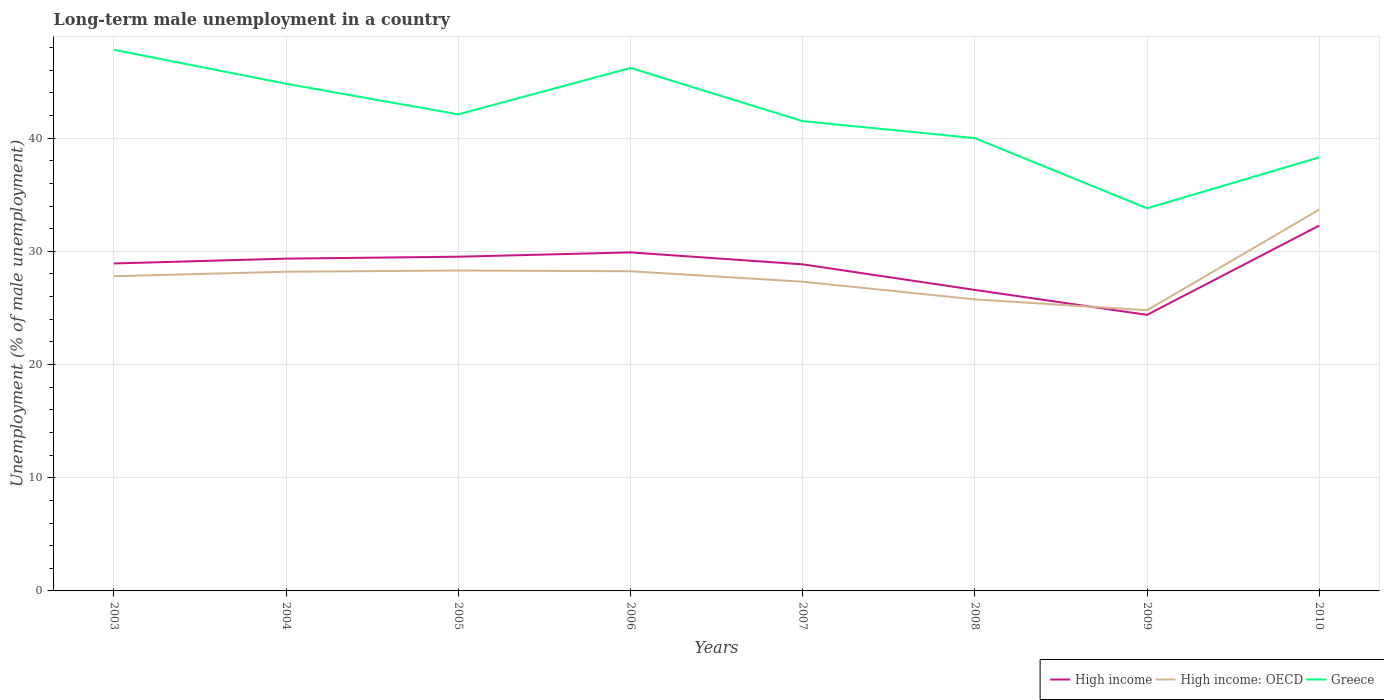How many different coloured lines are there?
Give a very brief answer. 3. Does the line corresponding to Greece intersect with the line corresponding to High income?
Give a very brief answer. No. Is the number of lines equal to the number of legend labels?
Offer a terse response. Yes. Across all years, what is the maximum percentage of long-term unemployed male population in High income?
Give a very brief answer. 24.39. What is the total percentage of long-term unemployed male population in High income in the graph?
Give a very brief answer. 1.06. What is the difference between the highest and the second highest percentage of long-term unemployed male population in High income?
Offer a terse response. 7.89. What is the difference between the highest and the lowest percentage of long-term unemployed male population in High income: OECD?
Provide a succinct answer. 4. Is the percentage of long-term unemployed male population in High income strictly greater than the percentage of long-term unemployed male population in Greece over the years?
Your answer should be compact. Yes. How many years are there in the graph?
Provide a short and direct response. 8. What is the difference between two consecutive major ticks on the Y-axis?
Keep it short and to the point. 10. Are the values on the major ticks of Y-axis written in scientific E-notation?
Make the answer very short. No. Does the graph contain any zero values?
Make the answer very short. No. Does the graph contain grids?
Give a very brief answer. Yes. How are the legend labels stacked?
Offer a very short reply. Horizontal. What is the title of the graph?
Give a very brief answer. Long-term male unemployment in a country. What is the label or title of the Y-axis?
Keep it short and to the point. Unemployment (% of male unemployment). What is the Unemployment (% of male unemployment) of High income in 2003?
Keep it short and to the point. 28.93. What is the Unemployment (% of male unemployment) in High income: OECD in 2003?
Offer a very short reply. 27.8. What is the Unemployment (% of male unemployment) of Greece in 2003?
Ensure brevity in your answer.  47.8. What is the Unemployment (% of male unemployment) in High income in 2004?
Your answer should be compact. 29.36. What is the Unemployment (% of male unemployment) in High income: OECD in 2004?
Offer a very short reply. 28.2. What is the Unemployment (% of male unemployment) in Greece in 2004?
Ensure brevity in your answer.  44.8. What is the Unemployment (% of male unemployment) in High income in 2005?
Your answer should be very brief. 29.52. What is the Unemployment (% of male unemployment) in High income: OECD in 2005?
Your response must be concise. 28.3. What is the Unemployment (% of male unemployment) in Greece in 2005?
Give a very brief answer. 42.1. What is the Unemployment (% of male unemployment) of High income in 2006?
Your answer should be compact. 29.91. What is the Unemployment (% of male unemployment) in High income: OECD in 2006?
Give a very brief answer. 28.24. What is the Unemployment (% of male unemployment) in Greece in 2006?
Ensure brevity in your answer.  46.2. What is the Unemployment (% of male unemployment) of High income in 2007?
Your answer should be very brief. 28.85. What is the Unemployment (% of male unemployment) of High income: OECD in 2007?
Your response must be concise. 27.32. What is the Unemployment (% of male unemployment) in Greece in 2007?
Your answer should be compact. 41.5. What is the Unemployment (% of male unemployment) of High income in 2008?
Offer a very short reply. 26.59. What is the Unemployment (% of male unemployment) of High income: OECD in 2008?
Give a very brief answer. 25.75. What is the Unemployment (% of male unemployment) of High income in 2009?
Provide a succinct answer. 24.39. What is the Unemployment (% of male unemployment) in High income: OECD in 2009?
Offer a terse response. 24.79. What is the Unemployment (% of male unemployment) of Greece in 2009?
Provide a succinct answer. 33.8. What is the Unemployment (% of male unemployment) in High income in 2010?
Provide a succinct answer. 32.28. What is the Unemployment (% of male unemployment) of High income: OECD in 2010?
Provide a succinct answer. 33.69. What is the Unemployment (% of male unemployment) in Greece in 2010?
Ensure brevity in your answer.  38.3. Across all years, what is the maximum Unemployment (% of male unemployment) of High income?
Give a very brief answer. 32.28. Across all years, what is the maximum Unemployment (% of male unemployment) of High income: OECD?
Your response must be concise. 33.69. Across all years, what is the maximum Unemployment (% of male unemployment) in Greece?
Provide a succinct answer. 47.8. Across all years, what is the minimum Unemployment (% of male unemployment) in High income?
Your response must be concise. 24.39. Across all years, what is the minimum Unemployment (% of male unemployment) in High income: OECD?
Ensure brevity in your answer.  24.79. Across all years, what is the minimum Unemployment (% of male unemployment) in Greece?
Offer a very short reply. 33.8. What is the total Unemployment (% of male unemployment) in High income in the graph?
Provide a succinct answer. 229.81. What is the total Unemployment (% of male unemployment) in High income: OECD in the graph?
Your response must be concise. 224.09. What is the total Unemployment (% of male unemployment) in Greece in the graph?
Ensure brevity in your answer.  334.5. What is the difference between the Unemployment (% of male unemployment) of High income in 2003 and that in 2004?
Your answer should be very brief. -0.43. What is the difference between the Unemployment (% of male unemployment) in High income: OECD in 2003 and that in 2004?
Make the answer very short. -0.39. What is the difference between the Unemployment (% of male unemployment) in Greece in 2003 and that in 2004?
Give a very brief answer. 3. What is the difference between the Unemployment (% of male unemployment) in High income in 2003 and that in 2005?
Your answer should be very brief. -0.6. What is the difference between the Unemployment (% of male unemployment) of High income: OECD in 2003 and that in 2005?
Provide a short and direct response. -0.5. What is the difference between the Unemployment (% of male unemployment) in Greece in 2003 and that in 2005?
Ensure brevity in your answer.  5.7. What is the difference between the Unemployment (% of male unemployment) in High income in 2003 and that in 2006?
Provide a short and direct response. -0.98. What is the difference between the Unemployment (% of male unemployment) in High income: OECD in 2003 and that in 2006?
Make the answer very short. -0.44. What is the difference between the Unemployment (% of male unemployment) of Greece in 2003 and that in 2006?
Give a very brief answer. 1.6. What is the difference between the Unemployment (% of male unemployment) of High income in 2003 and that in 2007?
Keep it short and to the point. 0.08. What is the difference between the Unemployment (% of male unemployment) in High income: OECD in 2003 and that in 2007?
Keep it short and to the point. 0.48. What is the difference between the Unemployment (% of male unemployment) in High income in 2003 and that in 2008?
Provide a succinct answer. 2.34. What is the difference between the Unemployment (% of male unemployment) in High income: OECD in 2003 and that in 2008?
Offer a very short reply. 2.05. What is the difference between the Unemployment (% of male unemployment) of Greece in 2003 and that in 2008?
Provide a succinct answer. 7.8. What is the difference between the Unemployment (% of male unemployment) in High income in 2003 and that in 2009?
Ensure brevity in your answer.  4.54. What is the difference between the Unemployment (% of male unemployment) of High income: OECD in 2003 and that in 2009?
Your answer should be very brief. 3.01. What is the difference between the Unemployment (% of male unemployment) of Greece in 2003 and that in 2009?
Your response must be concise. 14. What is the difference between the Unemployment (% of male unemployment) in High income in 2003 and that in 2010?
Your answer should be compact. -3.35. What is the difference between the Unemployment (% of male unemployment) in High income: OECD in 2003 and that in 2010?
Make the answer very short. -5.88. What is the difference between the Unemployment (% of male unemployment) in High income in 2004 and that in 2005?
Your answer should be compact. -0.17. What is the difference between the Unemployment (% of male unemployment) in High income: OECD in 2004 and that in 2005?
Your answer should be very brief. -0.11. What is the difference between the Unemployment (% of male unemployment) in Greece in 2004 and that in 2005?
Your answer should be compact. 2.7. What is the difference between the Unemployment (% of male unemployment) in High income in 2004 and that in 2006?
Give a very brief answer. -0.55. What is the difference between the Unemployment (% of male unemployment) of High income: OECD in 2004 and that in 2006?
Provide a short and direct response. -0.04. What is the difference between the Unemployment (% of male unemployment) of High income in 2004 and that in 2007?
Provide a short and direct response. 0.51. What is the difference between the Unemployment (% of male unemployment) of High income: OECD in 2004 and that in 2007?
Make the answer very short. 0.88. What is the difference between the Unemployment (% of male unemployment) of Greece in 2004 and that in 2007?
Your answer should be compact. 3.3. What is the difference between the Unemployment (% of male unemployment) in High income in 2004 and that in 2008?
Keep it short and to the point. 2.77. What is the difference between the Unemployment (% of male unemployment) of High income: OECD in 2004 and that in 2008?
Provide a succinct answer. 2.44. What is the difference between the Unemployment (% of male unemployment) of High income in 2004 and that in 2009?
Ensure brevity in your answer.  4.97. What is the difference between the Unemployment (% of male unemployment) in High income: OECD in 2004 and that in 2009?
Ensure brevity in your answer.  3.4. What is the difference between the Unemployment (% of male unemployment) in Greece in 2004 and that in 2009?
Provide a short and direct response. 11. What is the difference between the Unemployment (% of male unemployment) in High income in 2004 and that in 2010?
Your answer should be very brief. -2.92. What is the difference between the Unemployment (% of male unemployment) in High income: OECD in 2004 and that in 2010?
Provide a short and direct response. -5.49. What is the difference between the Unemployment (% of male unemployment) in High income in 2005 and that in 2006?
Offer a terse response. -0.38. What is the difference between the Unemployment (% of male unemployment) of High income: OECD in 2005 and that in 2006?
Offer a very short reply. 0.07. What is the difference between the Unemployment (% of male unemployment) of Greece in 2005 and that in 2006?
Offer a terse response. -4.1. What is the difference between the Unemployment (% of male unemployment) of High income in 2005 and that in 2007?
Offer a very short reply. 0.67. What is the difference between the Unemployment (% of male unemployment) of High income: OECD in 2005 and that in 2007?
Provide a succinct answer. 0.99. What is the difference between the Unemployment (% of male unemployment) of Greece in 2005 and that in 2007?
Offer a terse response. 0.6. What is the difference between the Unemployment (% of male unemployment) in High income in 2005 and that in 2008?
Give a very brief answer. 2.93. What is the difference between the Unemployment (% of male unemployment) of High income: OECD in 2005 and that in 2008?
Provide a succinct answer. 2.55. What is the difference between the Unemployment (% of male unemployment) in Greece in 2005 and that in 2008?
Keep it short and to the point. 2.1. What is the difference between the Unemployment (% of male unemployment) in High income in 2005 and that in 2009?
Your response must be concise. 5.13. What is the difference between the Unemployment (% of male unemployment) in High income: OECD in 2005 and that in 2009?
Provide a succinct answer. 3.51. What is the difference between the Unemployment (% of male unemployment) in High income in 2005 and that in 2010?
Give a very brief answer. -2.75. What is the difference between the Unemployment (% of male unemployment) in High income: OECD in 2005 and that in 2010?
Offer a terse response. -5.38. What is the difference between the Unemployment (% of male unemployment) in High income in 2006 and that in 2007?
Ensure brevity in your answer.  1.06. What is the difference between the Unemployment (% of male unemployment) of High income: OECD in 2006 and that in 2007?
Make the answer very short. 0.92. What is the difference between the Unemployment (% of male unemployment) in High income in 2006 and that in 2008?
Keep it short and to the point. 3.32. What is the difference between the Unemployment (% of male unemployment) of High income: OECD in 2006 and that in 2008?
Ensure brevity in your answer.  2.49. What is the difference between the Unemployment (% of male unemployment) in Greece in 2006 and that in 2008?
Offer a very short reply. 6.2. What is the difference between the Unemployment (% of male unemployment) in High income in 2006 and that in 2009?
Make the answer very short. 5.52. What is the difference between the Unemployment (% of male unemployment) in High income: OECD in 2006 and that in 2009?
Ensure brevity in your answer.  3.45. What is the difference between the Unemployment (% of male unemployment) of High income in 2006 and that in 2010?
Provide a succinct answer. -2.37. What is the difference between the Unemployment (% of male unemployment) in High income: OECD in 2006 and that in 2010?
Your answer should be compact. -5.45. What is the difference between the Unemployment (% of male unemployment) in High income in 2007 and that in 2008?
Provide a short and direct response. 2.26. What is the difference between the Unemployment (% of male unemployment) in High income: OECD in 2007 and that in 2008?
Ensure brevity in your answer.  1.56. What is the difference between the Unemployment (% of male unemployment) of Greece in 2007 and that in 2008?
Give a very brief answer. 1.5. What is the difference between the Unemployment (% of male unemployment) in High income in 2007 and that in 2009?
Offer a terse response. 4.46. What is the difference between the Unemployment (% of male unemployment) in High income: OECD in 2007 and that in 2009?
Make the answer very short. 2.52. What is the difference between the Unemployment (% of male unemployment) in High income in 2007 and that in 2010?
Offer a terse response. -3.43. What is the difference between the Unemployment (% of male unemployment) in High income: OECD in 2007 and that in 2010?
Give a very brief answer. -6.37. What is the difference between the Unemployment (% of male unemployment) of High income in 2008 and that in 2009?
Provide a short and direct response. 2.2. What is the difference between the Unemployment (% of male unemployment) in High income: OECD in 2008 and that in 2009?
Offer a very short reply. 0.96. What is the difference between the Unemployment (% of male unemployment) in Greece in 2008 and that in 2009?
Your answer should be compact. 6.2. What is the difference between the Unemployment (% of male unemployment) of High income in 2008 and that in 2010?
Offer a terse response. -5.69. What is the difference between the Unemployment (% of male unemployment) in High income: OECD in 2008 and that in 2010?
Keep it short and to the point. -7.93. What is the difference between the Unemployment (% of male unemployment) in High income in 2009 and that in 2010?
Make the answer very short. -7.89. What is the difference between the Unemployment (% of male unemployment) in High income: OECD in 2009 and that in 2010?
Ensure brevity in your answer.  -8.89. What is the difference between the Unemployment (% of male unemployment) of Greece in 2009 and that in 2010?
Your answer should be compact. -4.5. What is the difference between the Unemployment (% of male unemployment) in High income in 2003 and the Unemployment (% of male unemployment) in High income: OECD in 2004?
Provide a succinct answer. 0.73. What is the difference between the Unemployment (% of male unemployment) in High income in 2003 and the Unemployment (% of male unemployment) in Greece in 2004?
Ensure brevity in your answer.  -15.87. What is the difference between the Unemployment (% of male unemployment) in High income: OECD in 2003 and the Unemployment (% of male unemployment) in Greece in 2004?
Your answer should be compact. -17. What is the difference between the Unemployment (% of male unemployment) in High income in 2003 and the Unemployment (% of male unemployment) in High income: OECD in 2005?
Your answer should be very brief. 0.62. What is the difference between the Unemployment (% of male unemployment) in High income in 2003 and the Unemployment (% of male unemployment) in Greece in 2005?
Keep it short and to the point. -13.17. What is the difference between the Unemployment (% of male unemployment) of High income: OECD in 2003 and the Unemployment (% of male unemployment) of Greece in 2005?
Provide a short and direct response. -14.3. What is the difference between the Unemployment (% of male unemployment) in High income in 2003 and the Unemployment (% of male unemployment) in High income: OECD in 2006?
Keep it short and to the point. 0.69. What is the difference between the Unemployment (% of male unemployment) in High income in 2003 and the Unemployment (% of male unemployment) in Greece in 2006?
Make the answer very short. -17.27. What is the difference between the Unemployment (% of male unemployment) of High income: OECD in 2003 and the Unemployment (% of male unemployment) of Greece in 2006?
Provide a short and direct response. -18.4. What is the difference between the Unemployment (% of male unemployment) of High income in 2003 and the Unemployment (% of male unemployment) of High income: OECD in 2007?
Offer a terse response. 1.61. What is the difference between the Unemployment (% of male unemployment) of High income in 2003 and the Unemployment (% of male unemployment) of Greece in 2007?
Ensure brevity in your answer.  -12.57. What is the difference between the Unemployment (% of male unemployment) of High income: OECD in 2003 and the Unemployment (% of male unemployment) of Greece in 2007?
Give a very brief answer. -13.7. What is the difference between the Unemployment (% of male unemployment) in High income in 2003 and the Unemployment (% of male unemployment) in High income: OECD in 2008?
Keep it short and to the point. 3.17. What is the difference between the Unemployment (% of male unemployment) of High income in 2003 and the Unemployment (% of male unemployment) of Greece in 2008?
Provide a short and direct response. -11.07. What is the difference between the Unemployment (% of male unemployment) of High income: OECD in 2003 and the Unemployment (% of male unemployment) of Greece in 2008?
Keep it short and to the point. -12.2. What is the difference between the Unemployment (% of male unemployment) in High income in 2003 and the Unemployment (% of male unemployment) in High income: OECD in 2009?
Offer a very short reply. 4.13. What is the difference between the Unemployment (% of male unemployment) in High income in 2003 and the Unemployment (% of male unemployment) in Greece in 2009?
Your answer should be compact. -4.87. What is the difference between the Unemployment (% of male unemployment) in High income: OECD in 2003 and the Unemployment (% of male unemployment) in Greece in 2009?
Make the answer very short. -6. What is the difference between the Unemployment (% of male unemployment) of High income in 2003 and the Unemployment (% of male unemployment) of High income: OECD in 2010?
Offer a terse response. -4.76. What is the difference between the Unemployment (% of male unemployment) of High income in 2003 and the Unemployment (% of male unemployment) of Greece in 2010?
Offer a very short reply. -9.37. What is the difference between the Unemployment (% of male unemployment) of High income: OECD in 2003 and the Unemployment (% of male unemployment) of Greece in 2010?
Ensure brevity in your answer.  -10.5. What is the difference between the Unemployment (% of male unemployment) in High income in 2004 and the Unemployment (% of male unemployment) in High income: OECD in 2005?
Ensure brevity in your answer.  1.05. What is the difference between the Unemployment (% of male unemployment) in High income in 2004 and the Unemployment (% of male unemployment) in Greece in 2005?
Provide a succinct answer. -12.74. What is the difference between the Unemployment (% of male unemployment) in High income: OECD in 2004 and the Unemployment (% of male unemployment) in Greece in 2005?
Keep it short and to the point. -13.9. What is the difference between the Unemployment (% of male unemployment) in High income in 2004 and the Unemployment (% of male unemployment) in High income: OECD in 2006?
Provide a short and direct response. 1.12. What is the difference between the Unemployment (% of male unemployment) in High income in 2004 and the Unemployment (% of male unemployment) in Greece in 2006?
Ensure brevity in your answer.  -16.84. What is the difference between the Unemployment (% of male unemployment) in High income: OECD in 2004 and the Unemployment (% of male unemployment) in Greece in 2006?
Your answer should be very brief. -18. What is the difference between the Unemployment (% of male unemployment) in High income in 2004 and the Unemployment (% of male unemployment) in High income: OECD in 2007?
Make the answer very short. 2.04. What is the difference between the Unemployment (% of male unemployment) of High income in 2004 and the Unemployment (% of male unemployment) of Greece in 2007?
Give a very brief answer. -12.14. What is the difference between the Unemployment (% of male unemployment) in High income: OECD in 2004 and the Unemployment (% of male unemployment) in Greece in 2007?
Ensure brevity in your answer.  -13.3. What is the difference between the Unemployment (% of male unemployment) in High income in 2004 and the Unemployment (% of male unemployment) in High income: OECD in 2008?
Make the answer very short. 3.6. What is the difference between the Unemployment (% of male unemployment) in High income in 2004 and the Unemployment (% of male unemployment) in Greece in 2008?
Ensure brevity in your answer.  -10.64. What is the difference between the Unemployment (% of male unemployment) of High income: OECD in 2004 and the Unemployment (% of male unemployment) of Greece in 2008?
Your answer should be compact. -11.8. What is the difference between the Unemployment (% of male unemployment) of High income in 2004 and the Unemployment (% of male unemployment) of High income: OECD in 2009?
Your answer should be very brief. 4.56. What is the difference between the Unemployment (% of male unemployment) of High income in 2004 and the Unemployment (% of male unemployment) of Greece in 2009?
Ensure brevity in your answer.  -4.44. What is the difference between the Unemployment (% of male unemployment) of High income: OECD in 2004 and the Unemployment (% of male unemployment) of Greece in 2009?
Ensure brevity in your answer.  -5.6. What is the difference between the Unemployment (% of male unemployment) in High income in 2004 and the Unemployment (% of male unemployment) in High income: OECD in 2010?
Make the answer very short. -4.33. What is the difference between the Unemployment (% of male unemployment) of High income in 2004 and the Unemployment (% of male unemployment) of Greece in 2010?
Your answer should be compact. -8.94. What is the difference between the Unemployment (% of male unemployment) of High income: OECD in 2004 and the Unemployment (% of male unemployment) of Greece in 2010?
Give a very brief answer. -10.1. What is the difference between the Unemployment (% of male unemployment) in High income in 2005 and the Unemployment (% of male unemployment) in High income: OECD in 2006?
Keep it short and to the point. 1.28. What is the difference between the Unemployment (% of male unemployment) of High income in 2005 and the Unemployment (% of male unemployment) of Greece in 2006?
Offer a terse response. -16.68. What is the difference between the Unemployment (% of male unemployment) in High income: OECD in 2005 and the Unemployment (% of male unemployment) in Greece in 2006?
Your response must be concise. -17.9. What is the difference between the Unemployment (% of male unemployment) of High income in 2005 and the Unemployment (% of male unemployment) of High income: OECD in 2007?
Your answer should be very brief. 2.21. What is the difference between the Unemployment (% of male unemployment) of High income in 2005 and the Unemployment (% of male unemployment) of Greece in 2007?
Offer a terse response. -11.98. What is the difference between the Unemployment (% of male unemployment) in High income: OECD in 2005 and the Unemployment (% of male unemployment) in Greece in 2007?
Your answer should be compact. -13.2. What is the difference between the Unemployment (% of male unemployment) of High income in 2005 and the Unemployment (% of male unemployment) of High income: OECD in 2008?
Your response must be concise. 3.77. What is the difference between the Unemployment (% of male unemployment) in High income in 2005 and the Unemployment (% of male unemployment) in Greece in 2008?
Give a very brief answer. -10.48. What is the difference between the Unemployment (% of male unemployment) in High income: OECD in 2005 and the Unemployment (% of male unemployment) in Greece in 2008?
Keep it short and to the point. -11.7. What is the difference between the Unemployment (% of male unemployment) in High income in 2005 and the Unemployment (% of male unemployment) in High income: OECD in 2009?
Provide a succinct answer. 4.73. What is the difference between the Unemployment (% of male unemployment) in High income in 2005 and the Unemployment (% of male unemployment) in Greece in 2009?
Your response must be concise. -4.28. What is the difference between the Unemployment (% of male unemployment) of High income: OECD in 2005 and the Unemployment (% of male unemployment) of Greece in 2009?
Your response must be concise. -5.5. What is the difference between the Unemployment (% of male unemployment) of High income in 2005 and the Unemployment (% of male unemployment) of High income: OECD in 2010?
Provide a succinct answer. -4.16. What is the difference between the Unemployment (% of male unemployment) in High income in 2005 and the Unemployment (% of male unemployment) in Greece in 2010?
Your response must be concise. -8.78. What is the difference between the Unemployment (% of male unemployment) of High income: OECD in 2005 and the Unemployment (% of male unemployment) of Greece in 2010?
Make the answer very short. -10. What is the difference between the Unemployment (% of male unemployment) of High income in 2006 and the Unemployment (% of male unemployment) of High income: OECD in 2007?
Offer a very short reply. 2.59. What is the difference between the Unemployment (% of male unemployment) of High income in 2006 and the Unemployment (% of male unemployment) of Greece in 2007?
Ensure brevity in your answer.  -11.59. What is the difference between the Unemployment (% of male unemployment) in High income: OECD in 2006 and the Unemployment (% of male unemployment) in Greece in 2007?
Ensure brevity in your answer.  -13.26. What is the difference between the Unemployment (% of male unemployment) in High income in 2006 and the Unemployment (% of male unemployment) in High income: OECD in 2008?
Your response must be concise. 4.15. What is the difference between the Unemployment (% of male unemployment) of High income in 2006 and the Unemployment (% of male unemployment) of Greece in 2008?
Ensure brevity in your answer.  -10.09. What is the difference between the Unemployment (% of male unemployment) in High income: OECD in 2006 and the Unemployment (% of male unemployment) in Greece in 2008?
Make the answer very short. -11.76. What is the difference between the Unemployment (% of male unemployment) in High income in 2006 and the Unemployment (% of male unemployment) in High income: OECD in 2009?
Offer a very short reply. 5.11. What is the difference between the Unemployment (% of male unemployment) in High income in 2006 and the Unemployment (% of male unemployment) in Greece in 2009?
Your response must be concise. -3.89. What is the difference between the Unemployment (% of male unemployment) of High income: OECD in 2006 and the Unemployment (% of male unemployment) of Greece in 2009?
Give a very brief answer. -5.56. What is the difference between the Unemployment (% of male unemployment) in High income in 2006 and the Unemployment (% of male unemployment) in High income: OECD in 2010?
Keep it short and to the point. -3.78. What is the difference between the Unemployment (% of male unemployment) of High income in 2006 and the Unemployment (% of male unemployment) of Greece in 2010?
Your response must be concise. -8.39. What is the difference between the Unemployment (% of male unemployment) in High income: OECD in 2006 and the Unemployment (% of male unemployment) in Greece in 2010?
Give a very brief answer. -10.06. What is the difference between the Unemployment (% of male unemployment) of High income in 2007 and the Unemployment (% of male unemployment) of High income: OECD in 2008?
Keep it short and to the point. 3.09. What is the difference between the Unemployment (% of male unemployment) of High income in 2007 and the Unemployment (% of male unemployment) of Greece in 2008?
Give a very brief answer. -11.15. What is the difference between the Unemployment (% of male unemployment) of High income: OECD in 2007 and the Unemployment (% of male unemployment) of Greece in 2008?
Offer a very short reply. -12.68. What is the difference between the Unemployment (% of male unemployment) in High income in 2007 and the Unemployment (% of male unemployment) in High income: OECD in 2009?
Ensure brevity in your answer.  4.05. What is the difference between the Unemployment (% of male unemployment) of High income in 2007 and the Unemployment (% of male unemployment) of Greece in 2009?
Give a very brief answer. -4.95. What is the difference between the Unemployment (% of male unemployment) of High income: OECD in 2007 and the Unemployment (% of male unemployment) of Greece in 2009?
Keep it short and to the point. -6.48. What is the difference between the Unemployment (% of male unemployment) of High income in 2007 and the Unemployment (% of male unemployment) of High income: OECD in 2010?
Ensure brevity in your answer.  -4.84. What is the difference between the Unemployment (% of male unemployment) of High income in 2007 and the Unemployment (% of male unemployment) of Greece in 2010?
Make the answer very short. -9.45. What is the difference between the Unemployment (% of male unemployment) in High income: OECD in 2007 and the Unemployment (% of male unemployment) in Greece in 2010?
Offer a very short reply. -10.98. What is the difference between the Unemployment (% of male unemployment) in High income in 2008 and the Unemployment (% of male unemployment) in High income: OECD in 2009?
Make the answer very short. 1.8. What is the difference between the Unemployment (% of male unemployment) of High income in 2008 and the Unemployment (% of male unemployment) of Greece in 2009?
Give a very brief answer. -7.21. What is the difference between the Unemployment (% of male unemployment) of High income: OECD in 2008 and the Unemployment (% of male unemployment) of Greece in 2009?
Offer a very short reply. -8.05. What is the difference between the Unemployment (% of male unemployment) in High income in 2008 and the Unemployment (% of male unemployment) in High income: OECD in 2010?
Provide a short and direct response. -7.1. What is the difference between the Unemployment (% of male unemployment) in High income in 2008 and the Unemployment (% of male unemployment) in Greece in 2010?
Give a very brief answer. -11.71. What is the difference between the Unemployment (% of male unemployment) in High income: OECD in 2008 and the Unemployment (% of male unemployment) in Greece in 2010?
Offer a terse response. -12.55. What is the difference between the Unemployment (% of male unemployment) in High income in 2009 and the Unemployment (% of male unemployment) in High income: OECD in 2010?
Offer a terse response. -9.3. What is the difference between the Unemployment (% of male unemployment) of High income in 2009 and the Unemployment (% of male unemployment) of Greece in 2010?
Offer a very short reply. -13.91. What is the difference between the Unemployment (% of male unemployment) of High income: OECD in 2009 and the Unemployment (% of male unemployment) of Greece in 2010?
Your response must be concise. -13.51. What is the average Unemployment (% of male unemployment) in High income per year?
Your response must be concise. 28.73. What is the average Unemployment (% of male unemployment) in High income: OECD per year?
Keep it short and to the point. 28.01. What is the average Unemployment (% of male unemployment) in Greece per year?
Provide a short and direct response. 41.81. In the year 2003, what is the difference between the Unemployment (% of male unemployment) of High income and Unemployment (% of male unemployment) of High income: OECD?
Provide a succinct answer. 1.13. In the year 2003, what is the difference between the Unemployment (% of male unemployment) of High income and Unemployment (% of male unemployment) of Greece?
Your answer should be very brief. -18.87. In the year 2003, what is the difference between the Unemployment (% of male unemployment) of High income: OECD and Unemployment (% of male unemployment) of Greece?
Make the answer very short. -20. In the year 2004, what is the difference between the Unemployment (% of male unemployment) in High income and Unemployment (% of male unemployment) in High income: OECD?
Ensure brevity in your answer.  1.16. In the year 2004, what is the difference between the Unemployment (% of male unemployment) in High income and Unemployment (% of male unemployment) in Greece?
Offer a terse response. -15.44. In the year 2004, what is the difference between the Unemployment (% of male unemployment) of High income: OECD and Unemployment (% of male unemployment) of Greece?
Your answer should be very brief. -16.6. In the year 2005, what is the difference between the Unemployment (% of male unemployment) in High income and Unemployment (% of male unemployment) in High income: OECD?
Offer a very short reply. 1.22. In the year 2005, what is the difference between the Unemployment (% of male unemployment) in High income and Unemployment (% of male unemployment) in Greece?
Offer a terse response. -12.58. In the year 2005, what is the difference between the Unemployment (% of male unemployment) in High income: OECD and Unemployment (% of male unemployment) in Greece?
Offer a very short reply. -13.8. In the year 2006, what is the difference between the Unemployment (% of male unemployment) in High income and Unemployment (% of male unemployment) in High income: OECD?
Provide a short and direct response. 1.67. In the year 2006, what is the difference between the Unemployment (% of male unemployment) in High income and Unemployment (% of male unemployment) in Greece?
Keep it short and to the point. -16.29. In the year 2006, what is the difference between the Unemployment (% of male unemployment) in High income: OECD and Unemployment (% of male unemployment) in Greece?
Provide a succinct answer. -17.96. In the year 2007, what is the difference between the Unemployment (% of male unemployment) of High income and Unemployment (% of male unemployment) of High income: OECD?
Your answer should be very brief. 1.53. In the year 2007, what is the difference between the Unemployment (% of male unemployment) in High income and Unemployment (% of male unemployment) in Greece?
Offer a very short reply. -12.65. In the year 2007, what is the difference between the Unemployment (% of male unemployment) in High income: OECD and Unemployment (% of male unemployment) in Greece?
Offer a very short reply. -14.18. In the year 2008, what is the difference between the Unemployment (% of male unemployment) of High income and Unemployment (% of male unemployment) of High income: OECD?
Offer a very short reply. 0.83. In the year 2008, what is the difference between the Unemployment (% of male unemployment) of High income and Unemployment (% of male unemployment) of Greece?
Keep it short and to the point. -13.41. In the year 2008, what is the difference between the Unemployment (% of male unemployment) of High income: OECD and Unemployment (% of male unemployment) of Greece?
Your response must be concise. -14.25. In the year 2009, what is the difference between the Unemployment (% of male unemployment) of High income and Unemployment (% of male unemployment) of High income: OECD?
Offer a very short reply. -0.41. In the year 2009, what is the difference between the Unemployment (% of male unemployment) of High income and Unemployment (% of male unemployment) of Greece?
Ensure brevity in your answer.  -9.41. In the year 2009, what is the difference between the Unemployment (% of male unemployment) of High income: OECD and Unemployment (% of male unemployment) of Greece?
Give a very brief answer. -9.01. In the year 2010, what is the difference between the Unemployment (% of male unemployment) in High income and Unemployment (% of male unemployment) in High income: OECD?
Provide a succinct answer. -1.41. In the year 2010, what is the difference between the Unemployment (% of male unemployment) of High income and Unemployment (% of male unemployment) of Greece?
Offer a terse response. -6.02. In the year 2010, what is the difference between the Unemployment (% of male unemployment) of High income: OECD and Unemployment (% of male unemployment) of Greece?
Offer a very short reply. -4.61. What is the ratio of the Unemployment (% of male unemployment) of High income in 2003 to that in 2004?
Your response must be concise. 0.99. What is the ratio of the Unemployment (% of male unemployment) in High income: OECD in 2003 to that in 2004?
Make the answer very short. 0.99. What is the ratio of the Unemployment (% of male unemployment) of Greece in 2003 to that in 2004?
Your answer should be very brief. 1.07. What is the ratio of the Unemployment (% of male unemployment) of High income in 2003 to that in 2005?
Give a very brief answer. 0.98. What is the ratio of the Unemployment (% of male unemployment) of High income: OECD in 2003 to that in 2005?
Make the answer very short. 0.98. What is the ratio of the Unemployment (% of male unemployment) of Greece in 2003 to that in 2005?
Your answer should be compact. 1.14. What is the ratio of the Unemployment (% of male unemployment) of High income in 2003 to that in 2006?
Provide a succinct answer. 0.97. What is the ratio of the Unemployment (% of male unemployment) of High income: OECD in 2003 to that in 2006?
Your answer should be compact. 0.98. What is the ratio of the Unemployment (% of male unemployment) in Greece in 2003 to that in 2006?
Your response must be concise. 1.03. What is the ratio of the Unemployment (% of male unemployment) in High income in 2003 to that in 2007?
Give a very brief answer. 1. What is the ratio of the Unemployment (% of male unemployment) of High income: OECD in 2003 to that in 2007?
Your response must be concise. 1.02. What is the ratio of the Unemployment (% of male unemployment) of Greece in 2003 to that in 2007?
Ensure brevity in your answer.  1.15. What is the ratio of the Unemployment (% of male unemployment) of High income in 2003 to that in 2008?
Offer a very short reply. 1.09. What is the ratio of the Unemployment (% of male unemployment) of High income: OECD in 2003 to that in 2008?
Provide a short and direct response. 1.08. What is the ratio of the Unemployment (% of male unemployment) in Greece in 2003 to that in 2008?
Offer a very short reply. 1.2. What is the ratio of the Unemployment (% of male unemployment) in High income in 2003 to that in 2009?
Your response must be concise. 1.19. What is the ratio of the Unemployment (% of male unemployment) in High income: OECD in 2003 to that in 2009?
Provide a short and direct response. 1.12. What is the ratio of the Unemployment (% of male unemployment) of Greece in 2003 to that in 2009?
Offer a terse response. 1.41. What is the ratio of the Unemployment (% of male unemployment) in High income in 2003 to that in 2010?
Your answer should be very brief. 0.9. What is the ratio of the Unemployment (% of male unemployment) in High income: OECD in 2003 to that in 2010?
Provide a short and direct response. 0.83. What is the ratio of the Unemployment (% of male unemployment) of Greece in 2003 to that in 2010?
Provide a succinct answer. 1.25. What is the ratio of the Unemployment (% of male unemployment) of High income in 2004 to that in 2005?
Provide a short and direct response. 0.99. What is the ratio of the Unemployment (% of male unemployment) of High income: OECD in 2004 to that in 2005?
Make the answer very short. 1. What is the ratio of the Unemployment (% of male unemployment) of Greece in 2004 to that in 2005?
Provide a short and direct response. 1.06. What is the ratio of the Unemployment (% of male unemployment) in High income in 2004 to that in 2006?
Make the answer very short. 0.98. What is the ratio of the Unemployment (% of male unemployment) of Greece in 2004 to that in 2006?
Your answer should be compact. 0.97. What is the ratio of the Unemployment (% of male unemployment) of High income in 2004 to that in 2007?
Your answer should be compact. 1.02. What is the ratio of the Unemployment (% of male unemployment) in High income: OECD in 2004 to that in 2007?
Keep it short and to the point. 1.03. What is the ratio of the Unemployment (% of male unemployment) of Greece in 2004 to that in 2007?
Offer a terse response. 1.08. What is the ratio of the Unemployment (% of male unemployment) of High income in 2004 to that in 2008?
Offer a terse response. 1.1. What is the ratio of the Unemployment (% of male unemployment) in High income: OECD in 2004 to that in 2008?
Provide a succinct answer. 1.09. What is the ratio of the Unemployment (% of male unemployment) of Greece in 2004 to that in 2008?
Ensure brevity in your answer.  1.12. What is the ratio of the Unemployment (% of male unemployment) in High income in 2004 to that in 2009?
Your answer should be very brief. 1.2. What is the ratio of the Unemployment (% of male unemployment) of High income: OECD in 2004 to that in 2009?
Your answer should be compact. 1.14. What is the ratio of the Unemployment (% of male unemployment) in Greece in 2004 to that in 2009?
Provide a short and direct response. 1.33. What is the ratio of the Unemployment (% of male unemployment) in High income in 2004 to that in 2010?
Offer a terse response. 0.91. What is the ratio of the Unemployment (% of male unemployment) of High income: OECD in 2004 to that in 2010?
Provide a succinct answer. 0.84. What is the ratio of the Unemployment (% of male unemployment) in Greece in 2004 to that in 2010?
Keep it short and to the point. 1.17. What is the ratio of the Unemployment (% of male unemployment) in High income in 2005 to that in 2006?
Ensure brevity in your answer.  0.99. What is the ratio of the Unemployment (% of male unemployment) of Greece in 2005 to that in 2006?
Your answer should be very brief. 0.91. What is the ratio of the Unemployment (% of male unemployment) in High income in 2005 to that in 2007?
Keep it short and to the point. 1.02. What is the ratio of the Unemployment (% of male unemployment) of High income: OECD in 2005 to that in 2007?
Offer a very short reply. 1.04. What is the ratio of the Unemployment (% of male unemployment) of Greece in 2005 to that in 2007?
Offer a terse response. 1.01. What is the ratio of the Unemployment (% of male unemployment) in High income in 2005 to that in 2008?
Offer a very short reply. 1.11. What is the ratio of the Unemployment (% of male unemployment) in High income: OECD in 2005 to that in 2008?
Make the answer very short. 1.1. What is the ratio of the Unemployment (% of male unemployment) of Greece in 2005 to that in 2008?
Make the answer very short. 1.05. What is the ratio of the Unemployment (% of male unemployment) of High income in 2005 to that in 2009?
Offer a very short reply. 1.21. What is the ratio of the Unemployment (% of male unemployment) in High income: OECD in 2005 to that in 2009?
Keep it short and to the point. 1.14. What is the ratio of the Unemployment (% of male unemployment) of Greece in 2005 to that in 2009?
Your response must be concise. 1.25. What is the ratio of the Unemployment (% of male unemployment) of High income in 2005 to that in 2010?
Provide a short and direct response. 0.91. What is the ratio of the Unemployment (% of male unemployment) in High income: OECD in 2005 to that in 2010?
Ensure brevity in your answer.  0.84. What is the ratio of the Unemployment (% of male unemployment) of Greece in 2005 to that in 2010?
Your response must be concise. 1.1. What is the ratio of the Unemployment (% of male unemployment) of High income in 2006 to that in 2007?
Your answer should be compact. 1.04. What is the ratio of the Unemployment (% of male unemployment) in High income: OECD in 2006 to that in 2007?
Provide a short and direct response. 1.03. What is the ratio of the Unemployment (% of male unemployment) of Greece in 2006 to that in 2007?
Ensure brevity in your answer.  1.11. What is the ratio of the Unemployment (% of male unemployment) of High income in 2006 to that in 2008?
Give a very brief answer. 1.12. What is the ratio of the Unemployment (% of male unemployment) in High income: OECD in 2006 to that in 2008?
Your answer should be compact. 1.1. What is the ratio of the Unemployment (% of male unemployment) of Greece in 2006 to that in 2008?
Keep it short and to the point. 1.16. What is the ratio of the Unemployment (% of male unemployment) of High income in 2006 to that in 2009?
Ensure brevity in your answer.  1.23. What is the ratio of the Unemployment (% of male unemployment) of High income: OECD in 2006 to that in 2009?
Your answer should be very brief. 1.14. What is the ratio of the Unemployment (% of male unemployment) in Greece in 2006 to that in 2009?
Provide a short and direct response. 1.37. What is the ratio of the Unemployment (% of male unemployment) in High income in 2006 to that in 2010?
Provide a short and direct response. 0.93. What is the ratio of the Unemployment (% of male unemployment) in High income: OECD in 2006 to that in 2010?
Your answer should be very brief. 0.84. What is the ratio of the Unemployment (% of male unemployment) of Greece in 2006 to that in 2010?
Give a very brief answer. 1.21. What is the ratio of the Unemployment (% of male unemployment) in High income in 2007 to that in 2008?
Offer a terse response. 1.08. What is the ratio of the Unemployment (% of male unemployment) in High income: OECD in 2007 to that in 2008?
Give a very brief answer. 1.06. What is the ratio of the Unemployment (% of male unemployment) in Greece in 2007 to that in 2008?
Provide a succinct answer. 1.04. What is the ratio of the Unemployment (% of male unemployment) of High income in 2007 to that in 2009?
Give a very brief answer. 1.18. What is the ratio of the Unemployment (% of male unemployment) in High income: OECD in 2007 to that in 2009?
Offer a very short reply. 1.1. What is the ratio of the Unemployment (% of male unemployment) in Greece in 2007 to that in 2009?
Provide a succinct answer. 1.23. What is the ratio of the Unemployment (% of male unemployment) of High income in 2007 to that in 2010?
Make the answer very short. 0.89. What is the ratio of the Unemployment (% of male unemployment) in High income: OECD in 2007 to that in 2010?
Your response must be concise. 0.81. What is the ratio of the Unemployment (% of male unemployment) in Greece in 2007 to that in 2010?
Give a very brief answer. 1.08. What is the ratio of the Unemployment (% of male unemployment) in High income in 2008 to that in 2009?
Provide a succinct answer. 1.09. What is the ratio of the Unemployment (% of male unemployment) in High income: OECD in 2008 to that in 2009?
Provide a succinct answer. 1.04. What is the ratio of the Unemployment (% of male unemployment) in Greece in 2008 to that in 2009?
Your answer should be compact. 1.18. What is the ratio of the Unemployment (% of male unemployment) of High income in 2008 to that in 2010?
Offer a terse response. 0.82. What is the ratio of the Unemployment (% of male unemployment) of High income: OECD in 2008 to that in 2010?
Offer a very short reply. 0.76. What is the ratio of the Unemployment (% of male unemployment) in Greece in 2008 to that in 2010?
Provide a succinct answer. 1.04. What is the ratio of the Unemployment (% of male unemployment) in High income in 2009 to that in 2010?
Ensure brevity in your answer.  0.76. What is the ratio of the Unemployment (% of male unemployment) of High income: OECD in 2009 to that in 2010?
Give a very brief answer. 0.74. What is the ratio of the Unemployment (% of male unemployment) in Greece in 2009 to that in 2010?
Provide a short and direct response. 0.88. What is the difference between the highest and the second highest Unemployment (% of male unemployment) in High income?
Keep it short and to the point. 2.37. What is the difference between the highest and the second highest Unemployment (% of male unemployment) of High income: OECD?
Provide a succinct answer. 5.38. What is the difference between the highest and the second highest Unemployment (% of male unemployment) of Greece?
Offer a very short reply. 1.6. What is the difference between the highest and the lowest Unemployment (% of male unemployment) in High income?
Offer a very short reply. 7.89. What is the difference between the highest and the lowest Unemployment (% of male unemployment) in High income: OECD?
Your answer should be very brief. 8.89. 